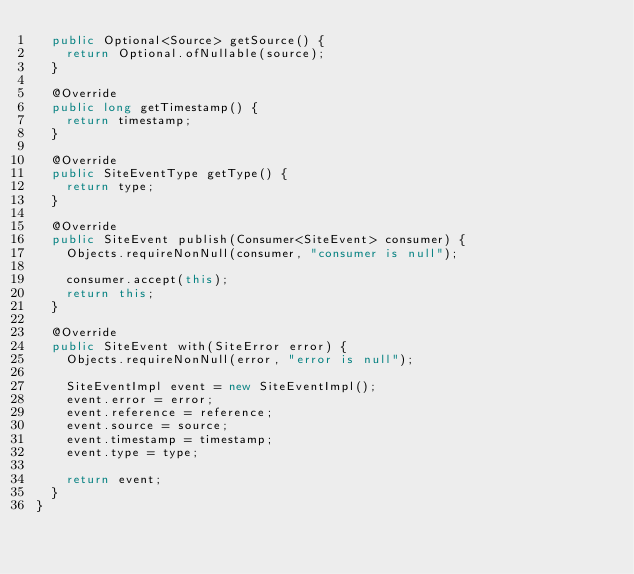Convert code to text. <code><loc_0><loc_0><loc_500><loc_500><_Java_>  public Optional<Source> getSource() {
    return Optional.ofNullable(source);
  }

  @Override
  public long getTimestamp() {
    return timestamp;
  }

  @Override
  public SiteEventType getType() {
    return type;
  }

  @Override
  public SiteEvent publish(Consumer<SiteEvent> consumer) {
    Objects.requireNonNull(consumer, "consumer is null");

    consumer.accept(this);
    return this;
  }

  @Override
  public SiteEvent with(SiteError error) {
    Objects.requireNonNull(error, "error is null");

    SiteEventImpl event = new SiteEventImpl();
    event.error = error;
    event.reference = reference;
    event.source = source;
    event.timestamp = timestamp;
    event.type = type;

    return event;
  }
}
</code> 